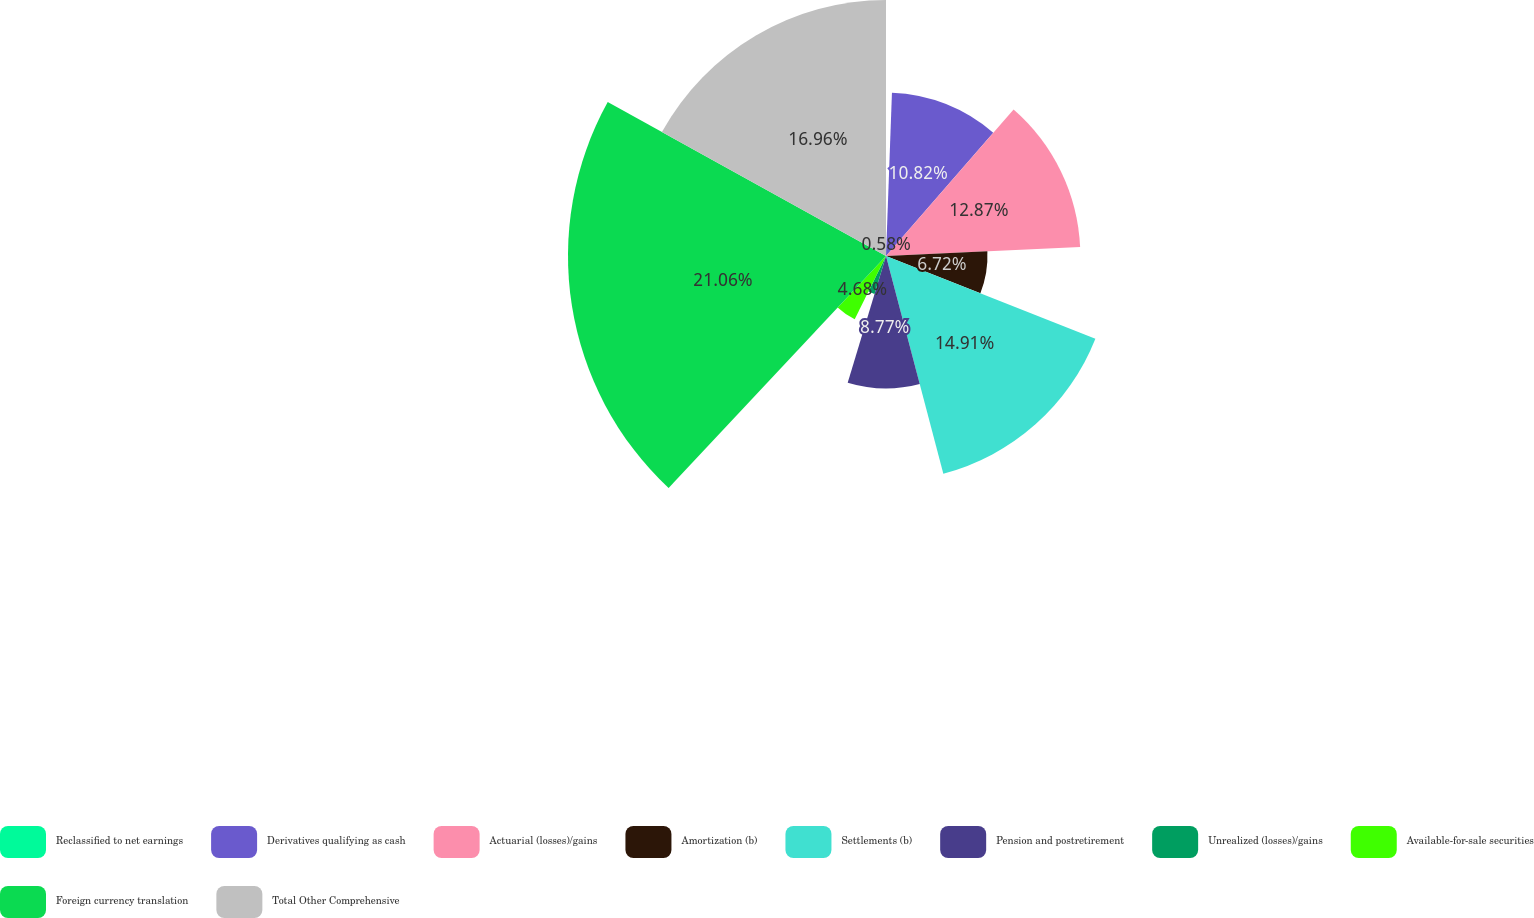<chart> <loc_0><loc_0><loc_500><loc_500><pie_chart><fcel>Reclassified to net earnings<fcel>Derivatives qualifying as cash<fcel>Actuarial (losses)/gains<fcel>Amortization (b)<fcel>Settlements (b)<fcel>Pension and postretirement<fcel>Unrealized (losses)/gains<fcel>Available-for-sale securities<fcel>Foreign currency translation<fcel>Total Other Comprehensive<nl><fcel>0.58%<fcel>10.82%<fcel>12.87%<fcel>6.72%<fcel>14.91%<fcel>8.77%<fcel>2.63%<fcel>4.68%<fcel>21.06%<fcel>16.96%<nl></chart> 